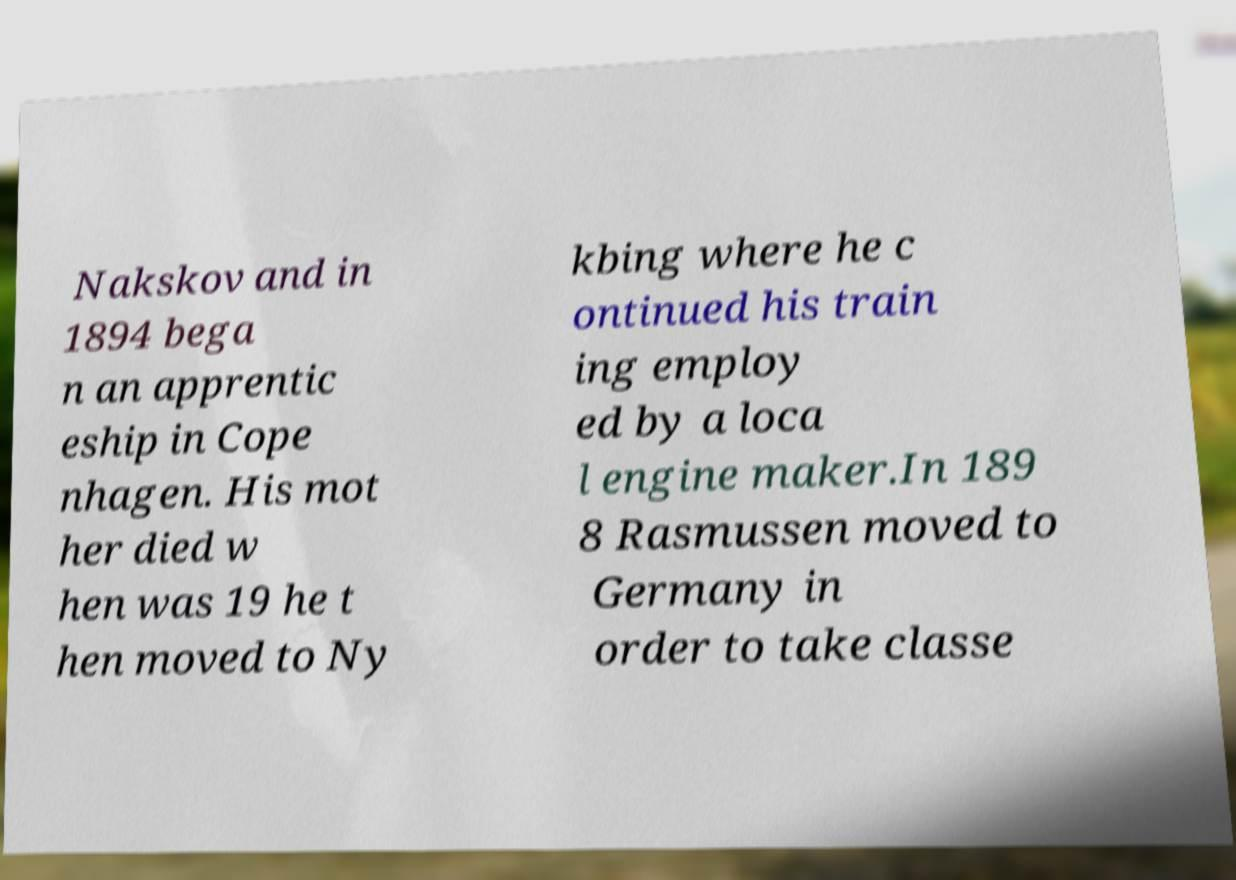I need the written content from this picture converted into text. Can you do that? Nakskov and in 1894 bega n an apprentic eship in Cope nhagen. His mot her died w hen was 19 he t hen moved to Ny kbing where he c ontinued his train ing employ ed by a loca l engine maker.In 189 8 Rasmussen moved to Germany in order to take classe 